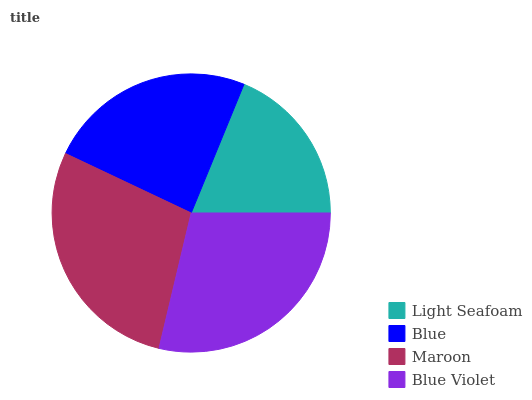Is Light Seafoam the minimum?
Answer yes or no. Yes. Is Blue Violet the maximum?
Answer yes or no. Yes. Is Blue the minimum?
Answer yes or no. No. Is Blue the maximum?
Answer yes or no. No. Is Blue greater than Light Seafoam?
Answer yes or no. Yes. Is Light Seafoam less than Blue?
Answer yes or no. Yes. Is Light Seafoam greater than Blue?
Answer yes or no. No. Is Blue less than Light Seafoam?
Answer yes or no. No. Is Maroon the high median?
Answer yes or no. Yes. Is Blue the low median?
Answer yes or no. Yes. Is Blue Violet the high median?
Answer yes or no. No. Is Maroon the low median?
Answer yes or no. No. 